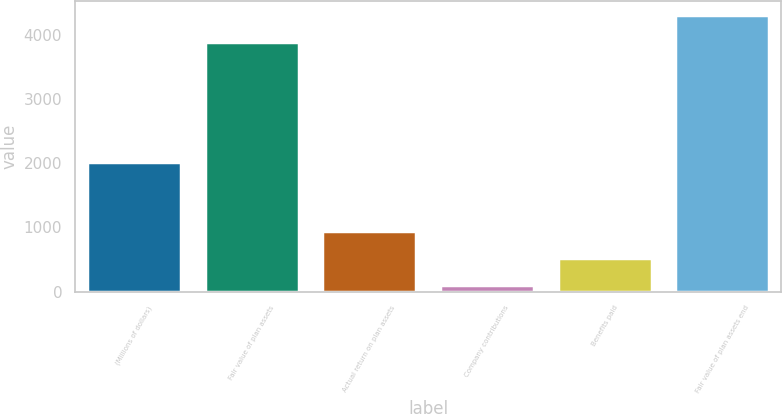Convert chart. <chart><loc_0><loc_0><loc_500><loc_500><bar_chart><fcel>(Millions of dollars)<fcel>Fair value of plan assets<fcel>Actual return on plan assets<fcel>Company contributions<fcel>Benefits paid<fcel>Fair value of plan assets end<nl><fcel>2017<fcel>3887<fcel>946.6<fcel>107<fcel>526.8<fcel>4306.8<nl></chart> 